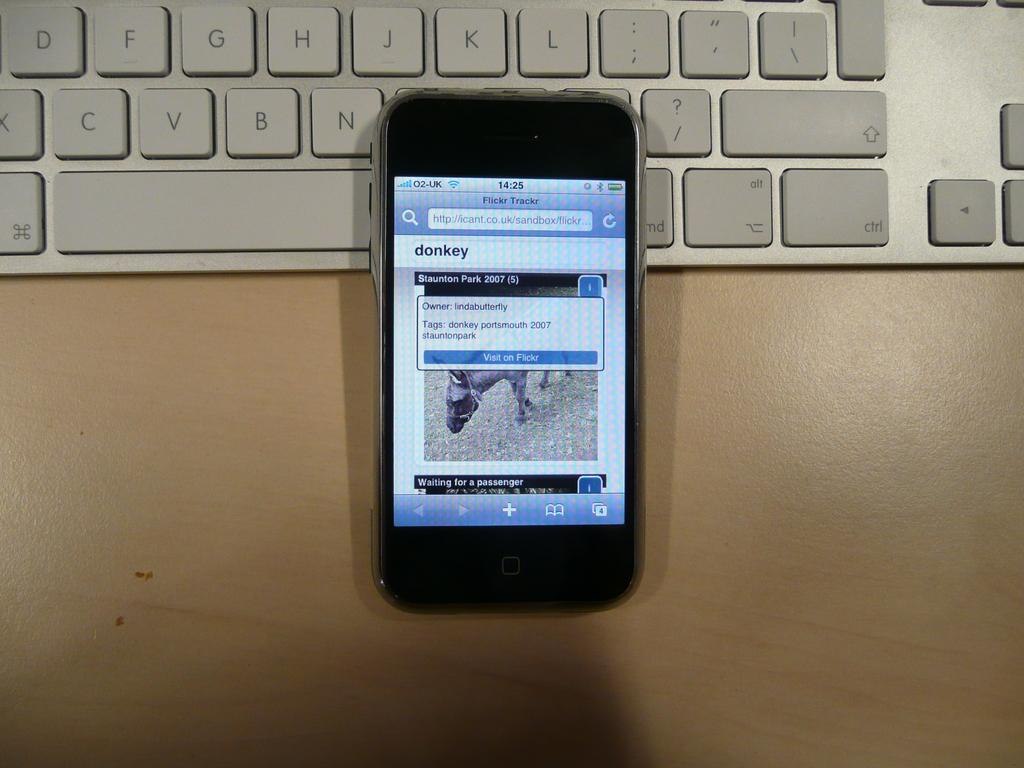What electronic device is visible in the image? There is a mobile-phone in the image. What other object related to technology can be seen in the image? There is a keyboard in the image. On what surface are the mobile-phone and keyboard placed? The mobile-phone and keyboard are on a brown color table. What type of oatmeal is being used as bait in the image? There is no oatmeal or bait present in the image; it features a mobile-phone and keyboard on a brown color table. What is the cause of death depicted in the image? There is no depiction of death or any related subject in the image. 